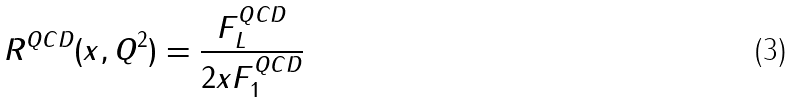Convert formula to latex. <formula><loc_0><loc_0><loc_500><loc_500>R ^ { Q C D } ( x , Q ^ { 2 } ) = \frac { F _ { L } ^ { Q C D } } { 2 x F _ { 1 } ^ { Q C D } }</formula> 